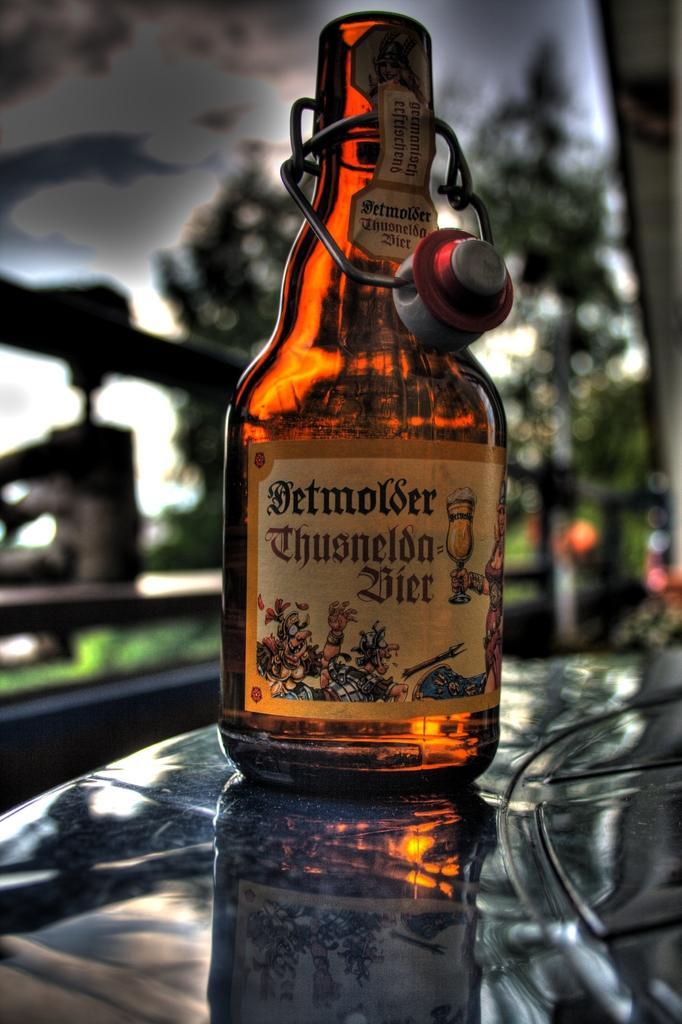Can you describe this image briefly? There is a wine bottle with open cap placed on a hood. There are trees in the background. The sky is covered with dark clouds. There is a fence over here. 